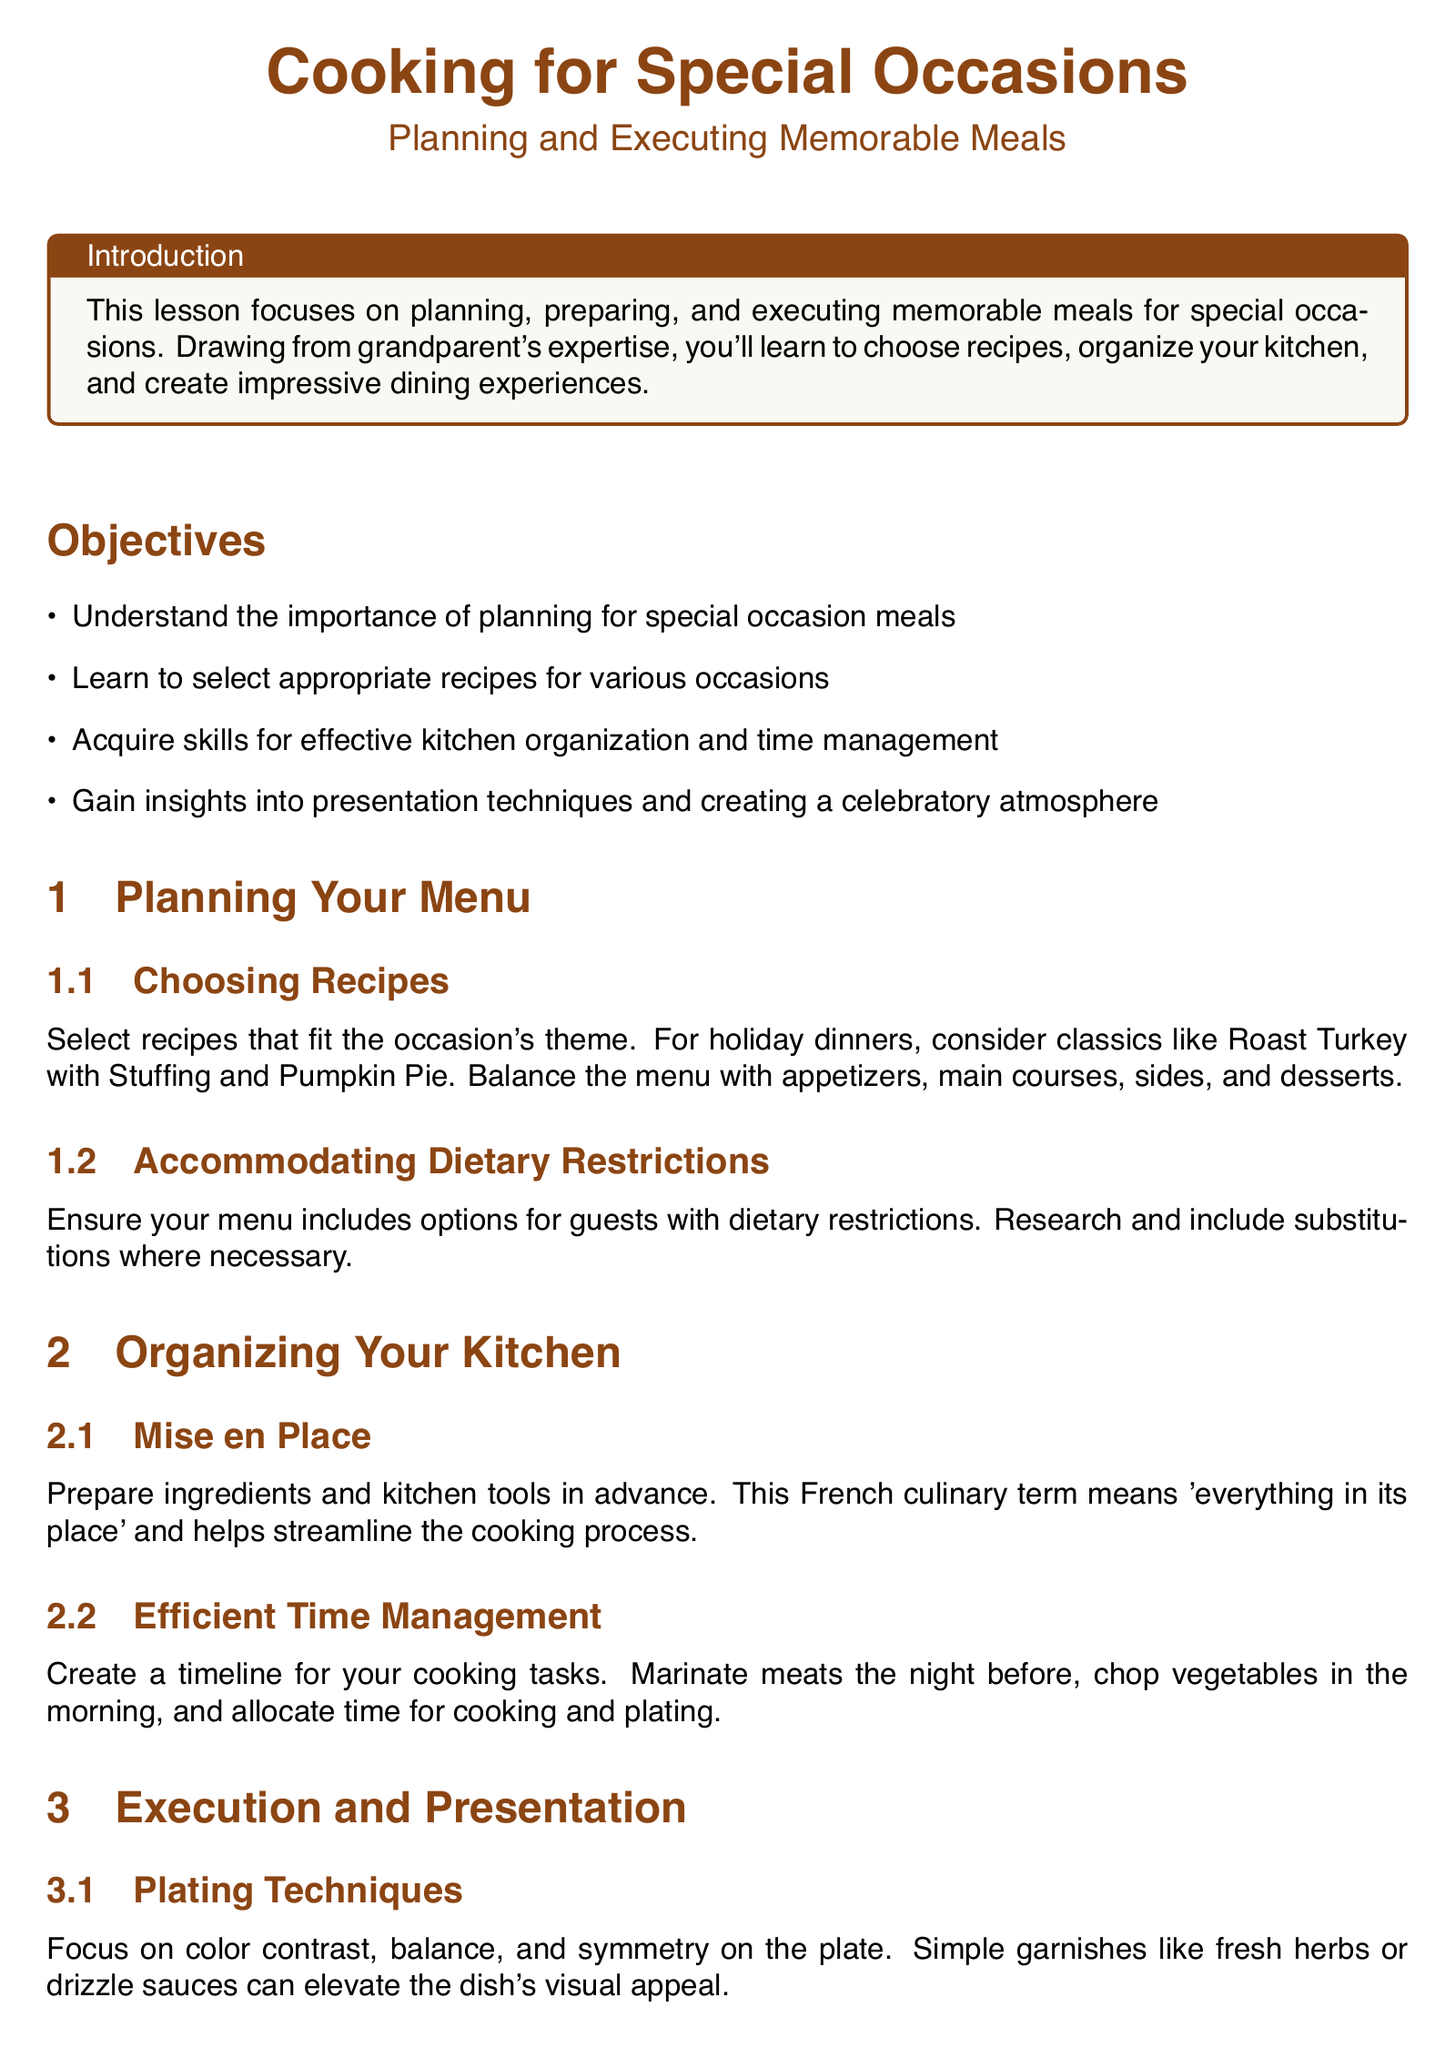What is the main focus of the lesson? The main focus of the lesson is on planning, preparing, and executing memorable meals for special occasions.
Answer: Planning, preparing, and executing memorable meals What are the two components of the assessment? The assessment includes a Menu Planning Exercise and a Time Management Plan, which involve developing a menu and a cooking schedule, respectively.
Answer: Menu Planning Exercise and Time Management Plan What culinary term refers to preparing ingredients in advance? The term 'Mise en Place' refers to preparing ingredients and kitchen tools in advance, helping streamline the cooking process.
Answer: Mise en Place What should the theme of the chosen recipes align with? The theme of the chosen recipes should align with the occasion for which the meal is being prepared.
Answer: Occasion Name one technique to create a celebratory atmosphere. One technique to create a celebratory atmosphere is to set the mood with appropriate table settings.
Answer: Table settings How many objectives are outlined in the lesson? The document lists four objectives relating to planning, recipe selection, kitchen organization, and presentation techniques.
Answer: Four What type of ambiance does the document suggest enhancing during special occasions? The document suggests enhancing the ambiance with appropriate lighting and background music during special occasions.
Answer: Lighting and background music What should you include for guests with dietary restrictions? The lesson advises ensuring the menu includes options for guests with dietary restrictions along with necessary substitutions.
Answer: Options for dietary restrictions 